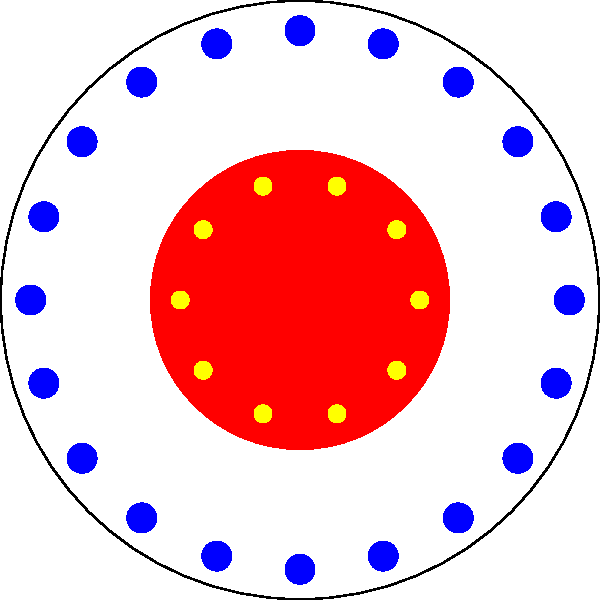In this Yayoi Kusama-inspired polka dot pattern, the large circle represents a canvas with a radius of 100 cm. The red circle in the center has a radius that is half of the canvas. Blue dots with a radius of 5 cm are arranged along the edge of the canvas, while yellow dots with a radius of 3 cm are placed around the red circle. What is the ratio of the area covered by the red circle to the total area of all blue and yellow dots combined? Let's approach this step-by-step:

1) Area of the red circle:
   $A_r = \pi r^2 = \pi (50)^2 = 2500\pi$ cm²

2) Area of each blue dot:
   $A_b = \pi r^2 = \pi (5)^2 = 25\pi$ cm²
   There are 20 blue dots, so total area: $20 * 25\pi = 500\pi$ cm²

3) Area of each yellow dot:
   $A_y = \pi r^2 = \pi (3)^2 = 9\pi$ cm²
   There are 10 yellow dots, so total area: $10 * 9\pi = 90\pi$ cm²

4) Total area of blue and yellow dots:
   $A_{total} = 500\pi + 90\pi = 590\pi$ cm²

5) Ratio of red circle area to total dot area:
   $\frac{A_r}{A_{total}} = \frac{2500\pi}{590\pi} = \frac{2500}{590} \approx 4.24$

Therefore, the ratio of the area of the red circle to the total area of all dots is 2500:590, which simplifies to 125:29.
Answer: 125:29 